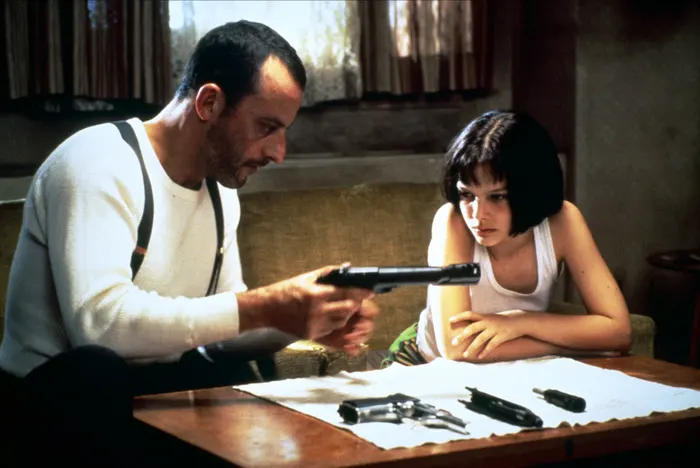Explain the visual content of the image in great detail. In the image, a scene from the movie "Léon: The Professional" is depicted. The two central characters, Léon and Mathilda, are seated at a wooden table in a dimly lit room. Léon, portrayed by Jean Reno, is dressed in a white long-sleeve shirt with suspenders. He is handling a black gun, pointing it thoughtfully at a piece of paper spread out on the table. Mathilda, played by Natalie Portman, is sitting next to him, wearing a white tank top and a black choker necklace. Her short bob haircut frames her concerned and focused expression as she watches Léon. The table is cluttered with several items, including other guns laying beside the paper. The backdrop of the room features a beige wall, a small window with curtains allowing soft light to enter, and a potted plant, contributing to the tense yet intimate ambiance of the scene. 